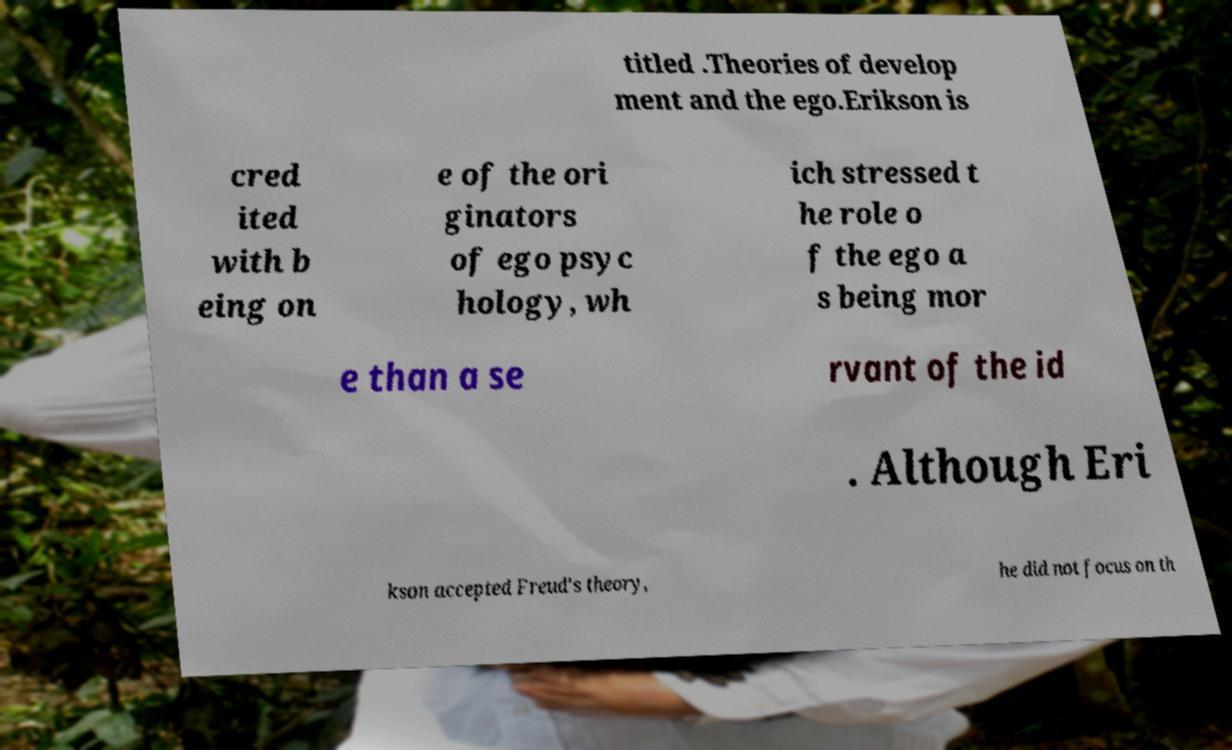There's text embedded in this image that I need extracted. Can you transcribe it verbatim? titled .Theories of develop ment and the ego.Erikson is cred ited with b eing on e of the ori ginators of ego psyc hology, wh ich stressed t he role o f the ego a s being mor e than a se rvant of the id . Although Eri kson accepted Freud's theory, he did not focus on th 